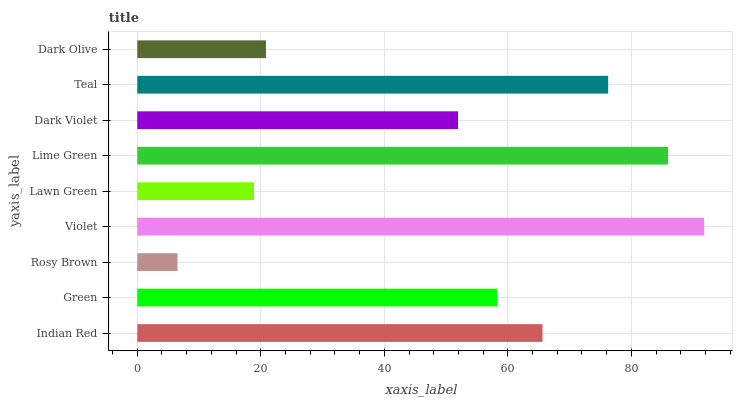Is Rosy Brown the minimum?
Answer yes or no. Yes. Is Violet the maximum?
Answer yes or no. Yes. Is Green the minimum?
Answer yes or no. No. Is Green the maximum?
Answer yes or no. No. Is Indian Red greater than Green?
Answer yes or no. Yes. Is Green less than Indian Red?
Answer yes or no. Yes. Is Green greater than Indian Red?
Answer yes or no. No. Is Indian Red less than Green?
Answer yes or no. No. Is Green the high median?
Answer yes or no. Yes. Is Green the low median?
Answer yes or no. Yes. Is Teal the high median?
Answer yes or no. No. Is Violet the low median?
Answer yes or no. No. 